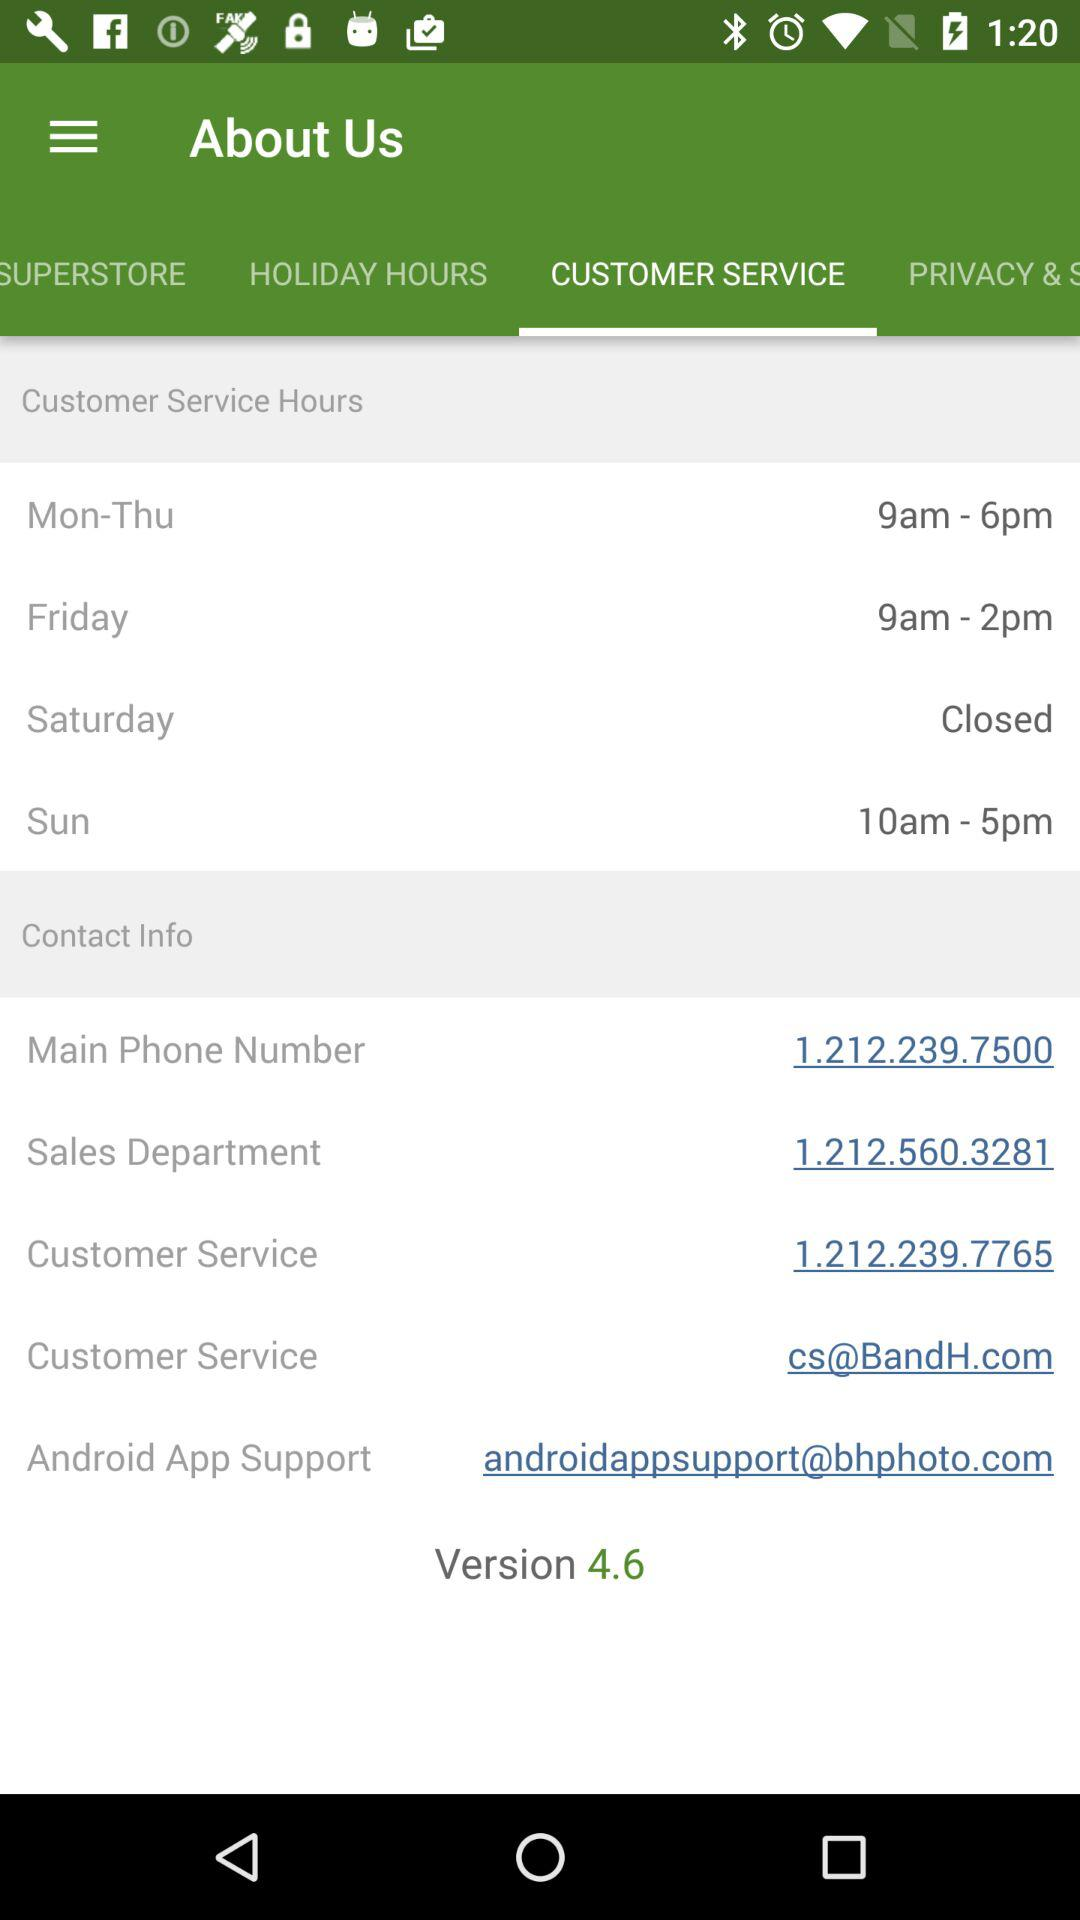What is the main phone number? The main phone number is 1.212.239.7500. 